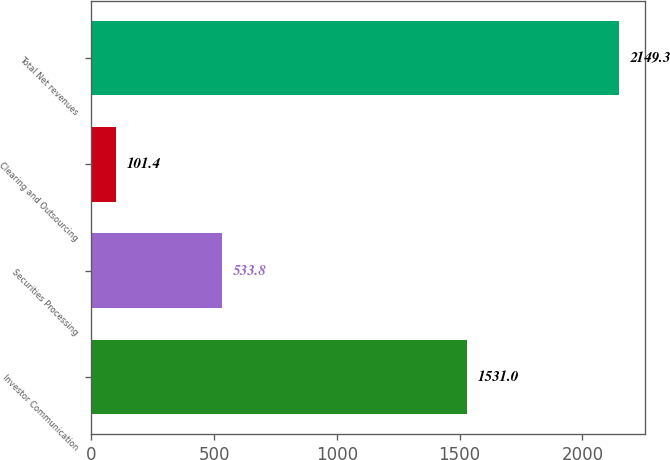<chart> <loc_0><loc_0><loc_500><loc_500><bar_chart><fcel>Investor Communication<fcel>Securities Processing<fcel>Clearing and Outsourcing<fcel>Total Net revenues<nl><fcel>1531<fcel>533.8<fcel>101.4<fcel>2149.3<nl></chart> 